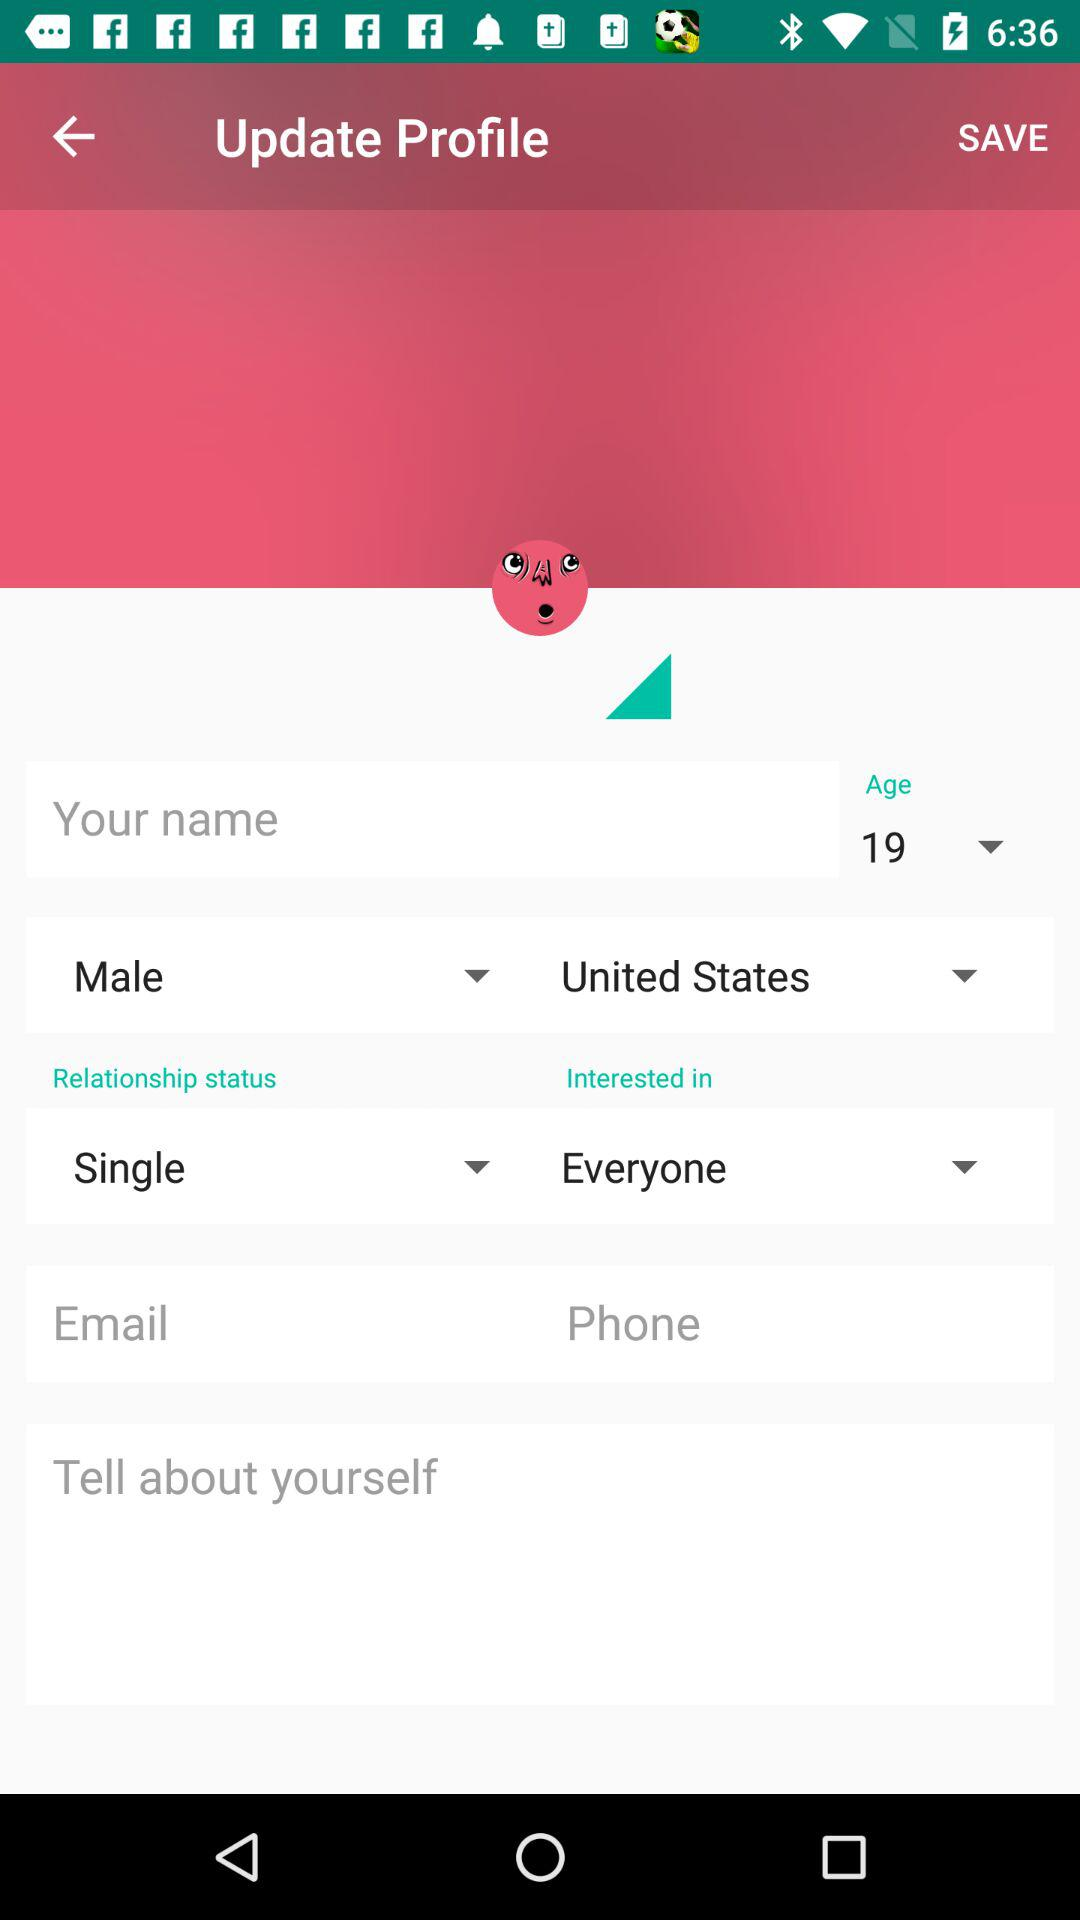What is the gender of the user? The gender of the user is male. 